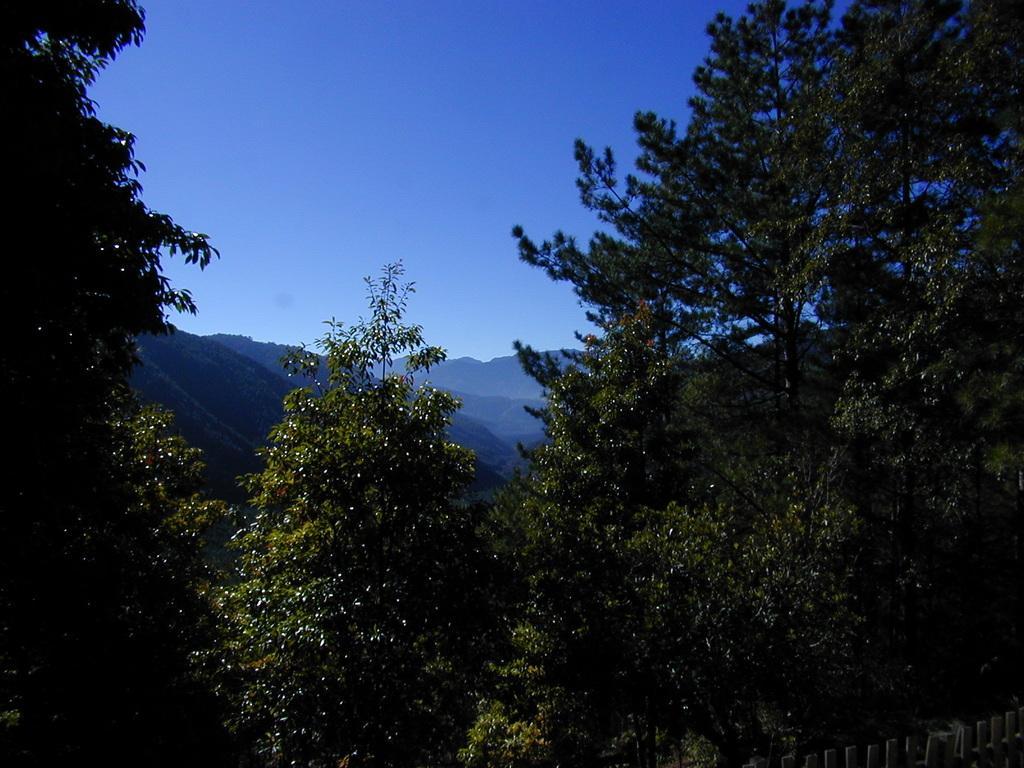In one or two sentences, can you explain what this image depicts? This image consists of trees in the front. There are mountains in the background. On the bottom right there is a wooden fence. 